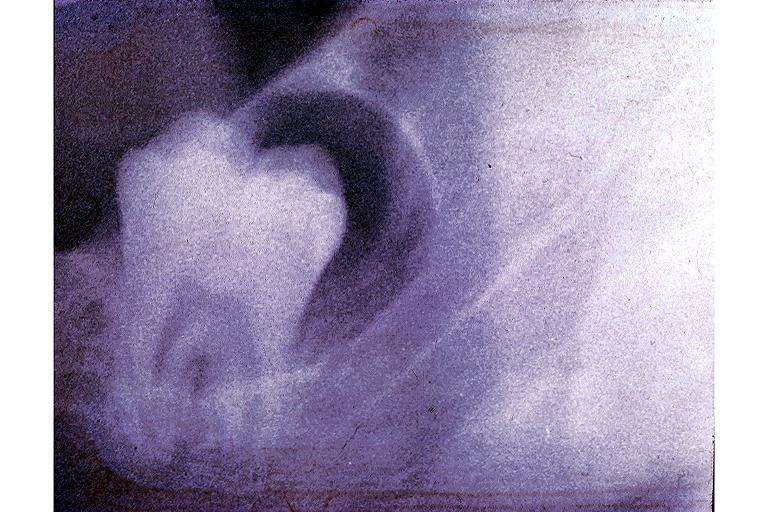where is this?
Answer the question using a single word or phrase. Oral 